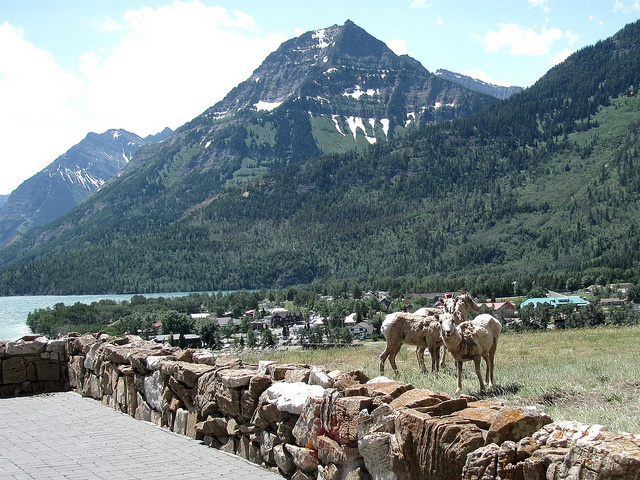Describe the objects in this image and their specific colors. I can see sheep in lightblue, gray, black, and white tones, sheep in lightblue, gray, and black tones, sheep in lightblue, gray, darkgray, and black tones, sheep in lightblue, white, gray, darkgray, and black tones, and sheep in lightblue, gray, and black tones in this image. 